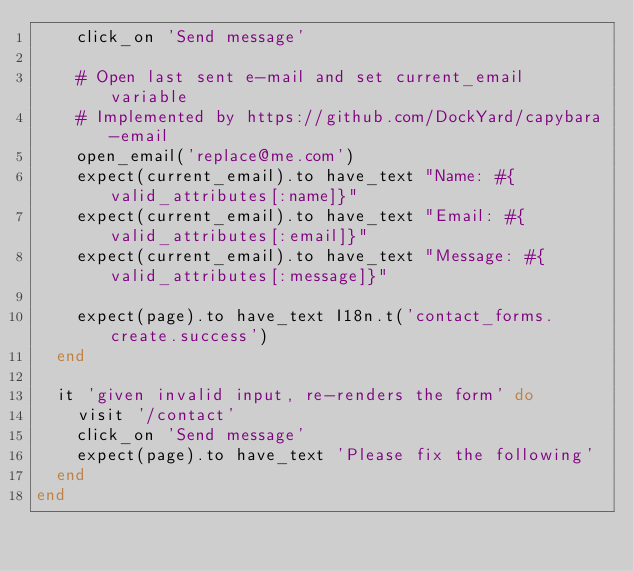Convert code to text. <code><loc_0><loc_0><loc_500><loc_500><_Ruby_>    click_on 'Send message'

    # Open last sent e-mail and set current_email variable
    # Implemented by https://github.com/DockYard/capybara-email
    open_email('replace@me.com')
    expect(current_email).to have_text "Name: #{valid_attributes[:name]}"
    expect(current_email).to have_text "Email: #{valid_attributes[:email]}"
    expect(current_email).to have_text "Message: #{valid_attributes[:message]}"

    expect(page).to have_text I18n.t('contact_forms.create.success')
  end

  it 'given invalid input, re-renders the form' do
    visit '/contact'
    click_on 'Send message'
    expect(page).to have_text 'Please fix the following'
  end
end
</code> 